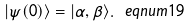<formula> <loc_0><loc_0><loc_500><loc_500>| \psi ( 0 ) \rangle = | \alpha , \beta \rangle . \ e q n u m { 1 9 }</formula> 